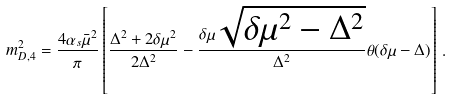Convert formula to latex. <formula><loc_0><loc_0><loc_500><loc_500>m _ { D , 4 } ^ { 2 } = \frac { 4 \alpha _ { s } \bar { \mu } ^ { 2 } } { \pi } \left [ \frac { \Delta ^ { 2 } + 2 \delta \mu ^ { 2 } } { 2 \Delta ^ { 2 } } - \frac { \delta \mu \sqrt { \delta \mu ^ { 2 } - \Delta ^ { 2 } } } { \Delta ^ { 2 } } \theta ( \delta \mu - \Delta ) \right ] \, .</formula> 